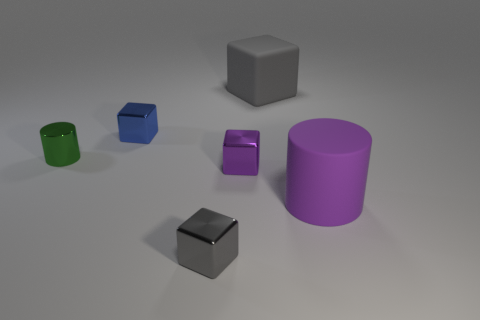Subtract 2 cubes. How many cubes are left? 2 Subtract all purple blocks. How many blocks are left? 3 Subtract all tiny shiny cubes. How many cubes are left? 1 Add 2 yellow matte cylinders. How many objects exist? 8 Subtract all purple cylinders. Subtract all blue balls. How many cylinders are left? 1 Subtract all cubes. How many objects are left? 2 Add 3 small metal spheres. How many small metal spheres exist? 3 Subtract 0 blue spheres. How many objects are left? 6 Subtract all gray rubber cubes. Subtract all tiny purple shiny objects. How many objects are left? 4 Add 5 small purple things. How many small purple things are left? 6 